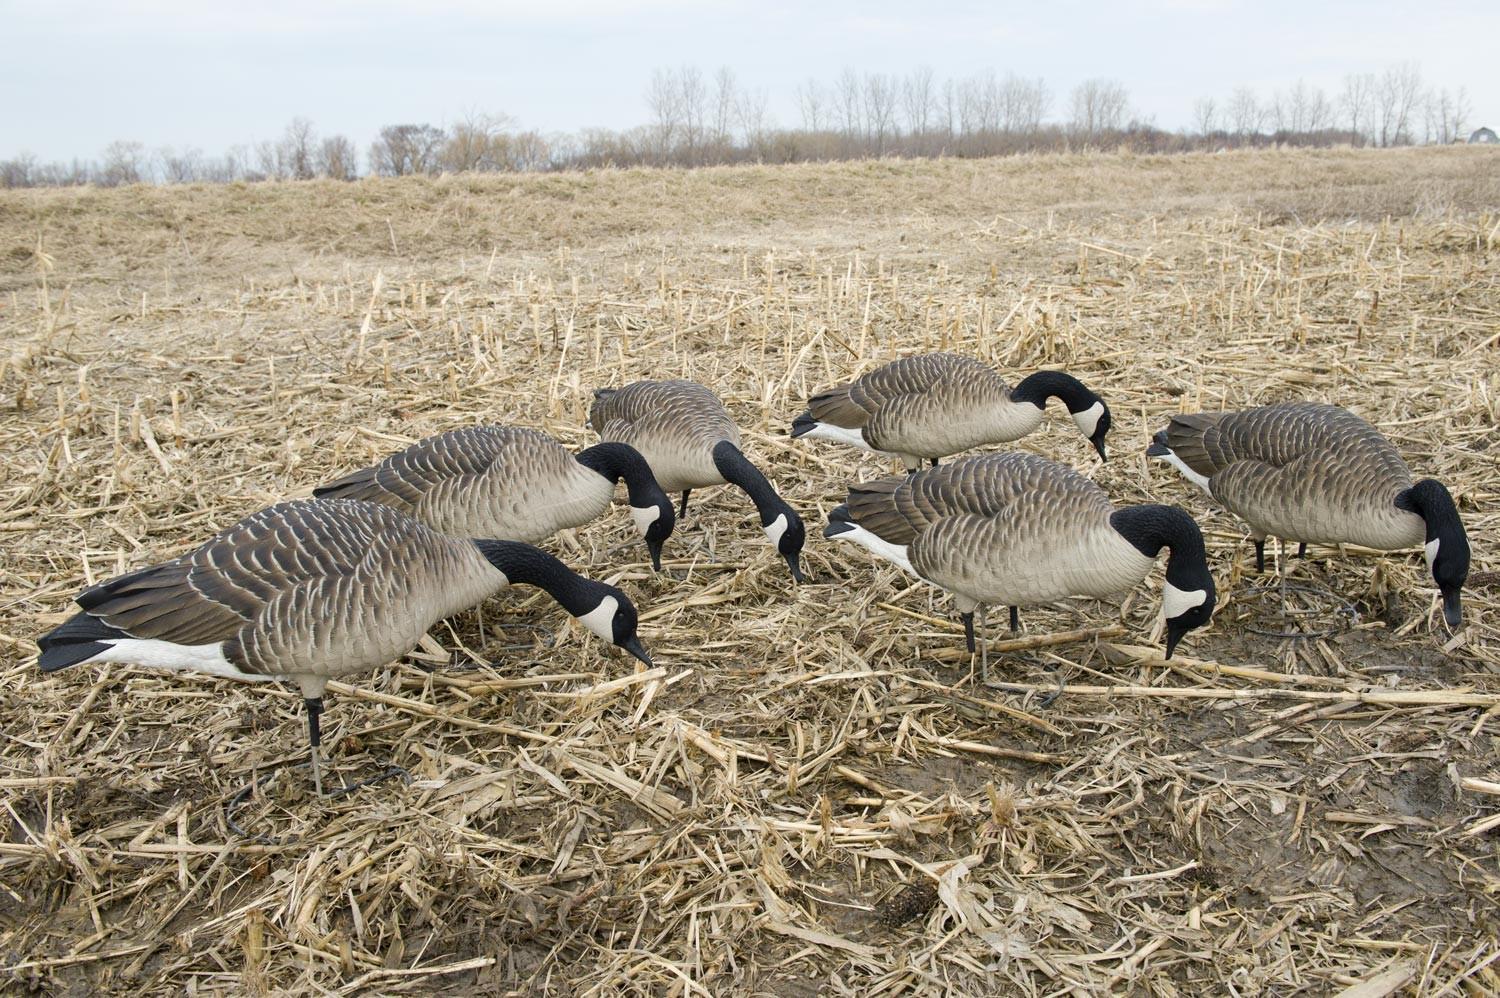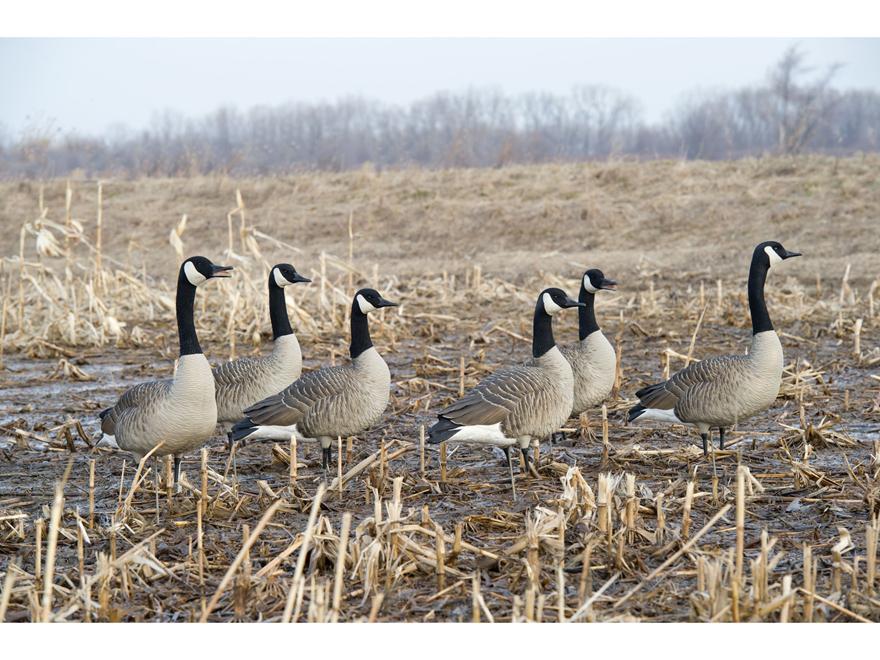The first image is the image on the left, the second image is the image on the right. Given the left and right images, does the statement "There are 18 or more Canadian Geese in open fields." hold true? Answer yes or no. No. 